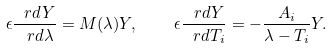Convert formula to latex. <formula><loc_0><loc_0><loc_500><loc_500>\epsilon \frac { \ r d Y } { \ r d \lambda } = M ( \lambda ) Y , \quad \epsilon \frac { \ r d Y } { \ r d T _ { i } } = - \frac { A _ { i } } { \lambda - T _ { i } } Y .</formula> 